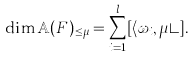<formula> <loc_0><loc_0><loc_500><loc_500>\dim \mathbb { A } ( F ) _ { \leq \mu } = \sum _ { i = 1 } ^ { l } [ \langle \omega _ { i } , \mu \rangle ] .</formula> 